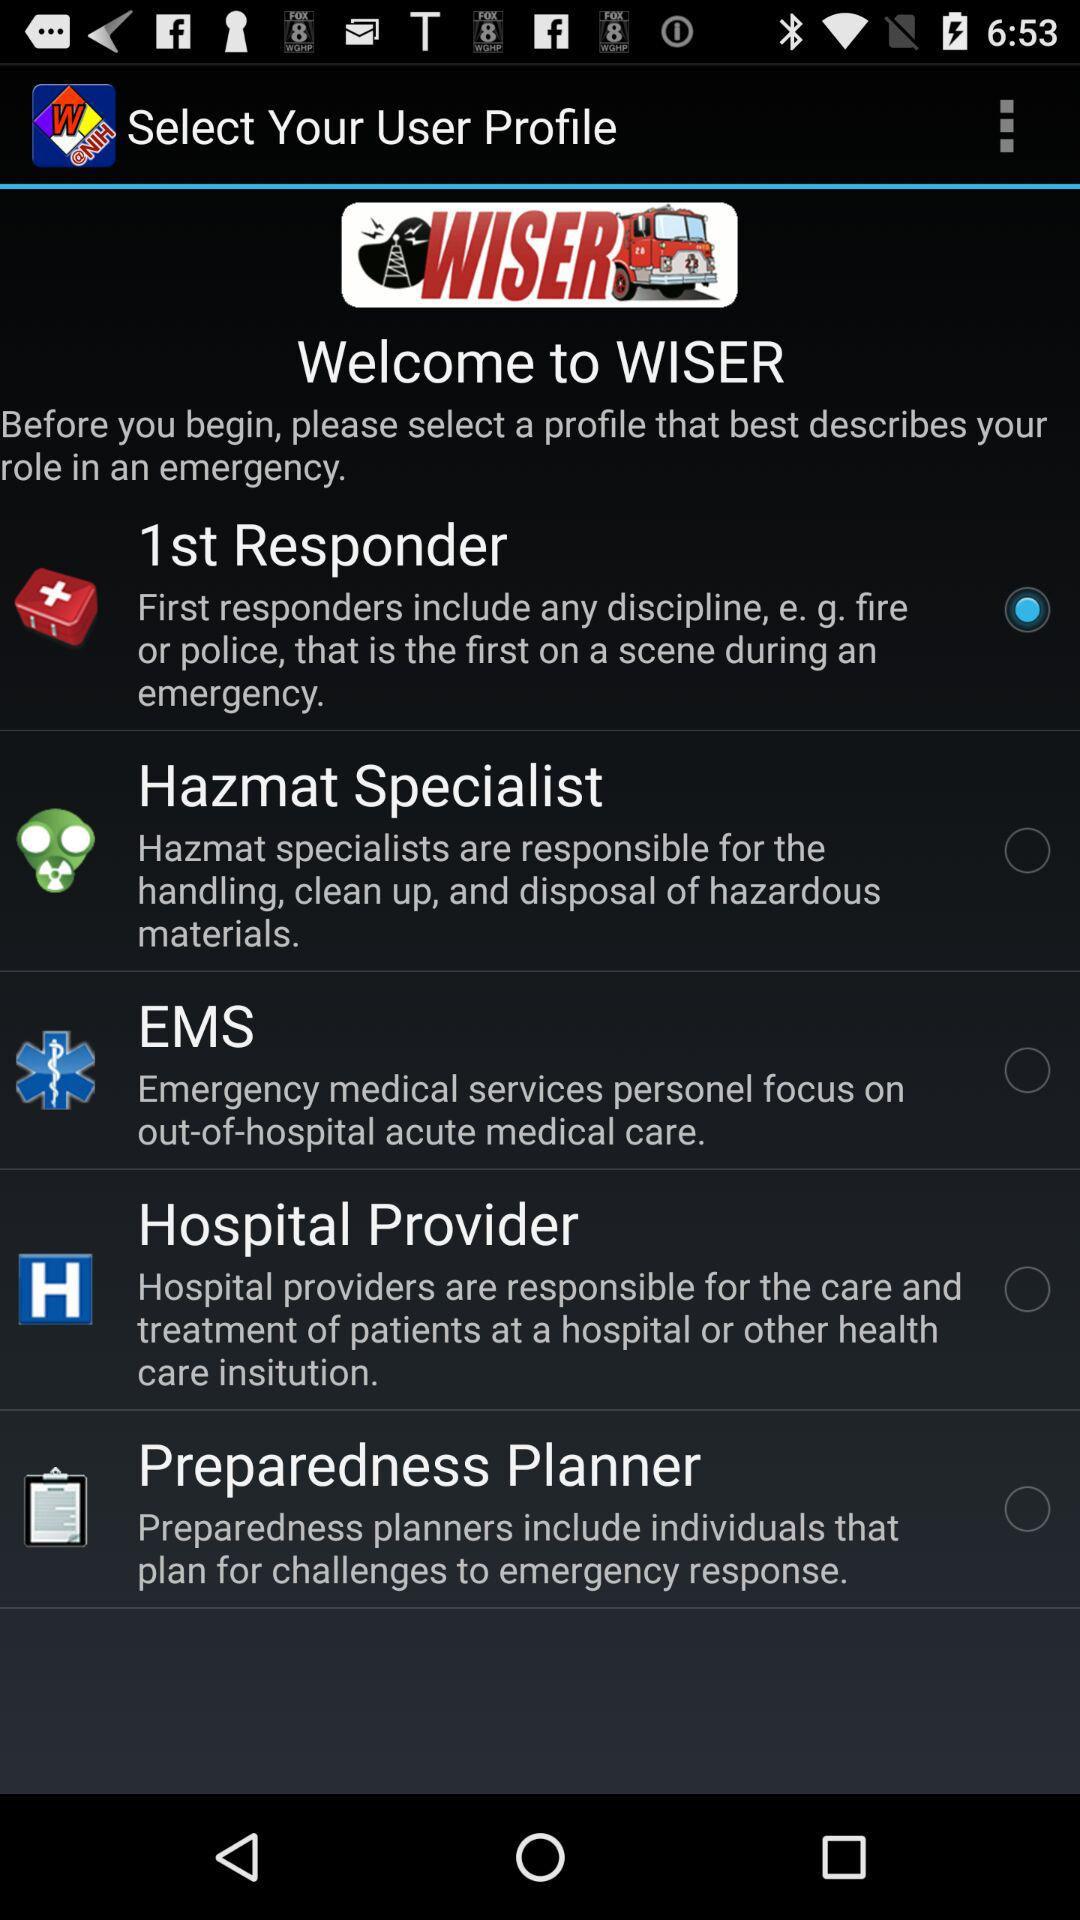What option is selected? The selected option is "1st Responder". 